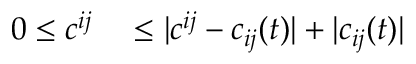<formula> <loc_0><loc_0><loc_500><loc_500>\begin{array} { r l } { 0 \leq c ^ { i j } } & \leq | c ^ { i j } - c _ { i j } ( t ) | + | c _ { i j } ( t ) | } \end{array}</formula> 